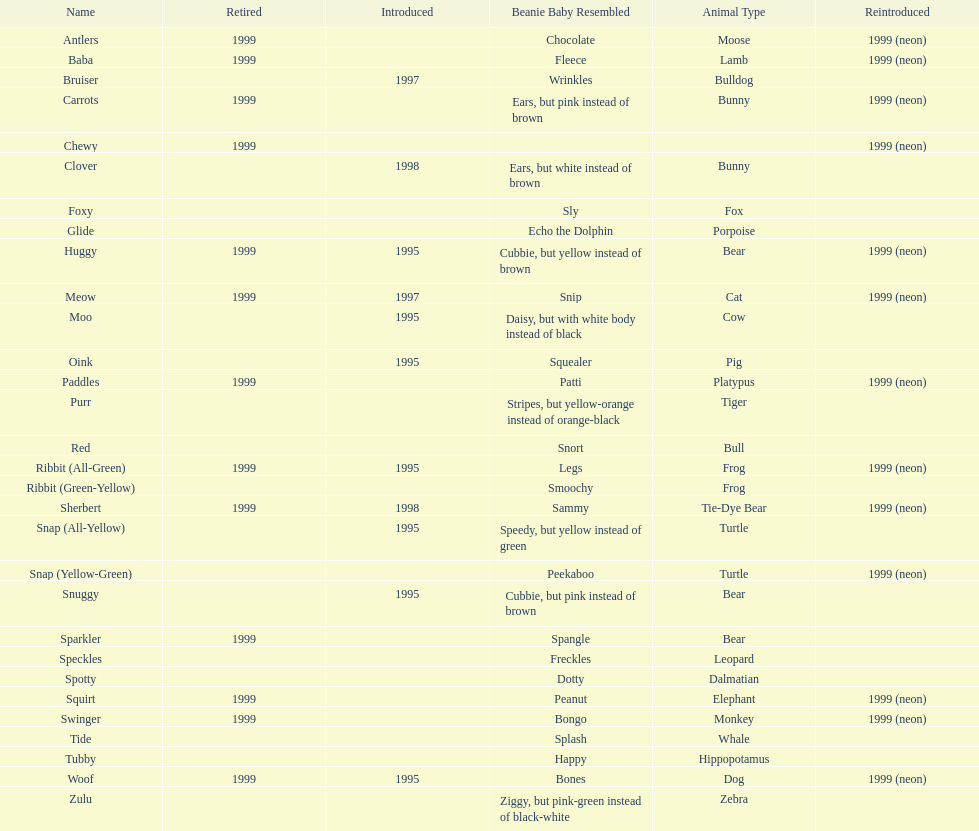Tell me the number of pillow pals reintroduced in 1999. 13. 